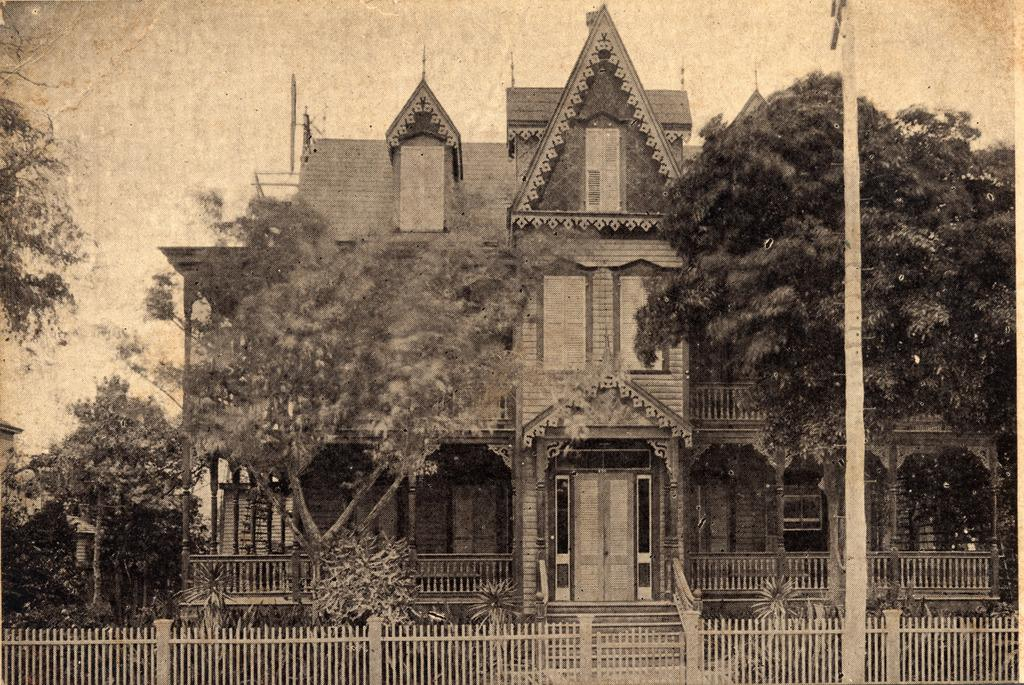What type of structure is visible in the image? There is a building in the image. What natural elements can be seen in the image? There are trees and plants in the image. What man-made object is present in the image? There is an electrical pole in the image. What type of barrier is visible in the image? There is a metal fence in the image. What type of business is being conducted in the image? There is no indication of any business activity in the image. What discovery was made by the passenger in the image? There is no passenger or discovery present in the image. 